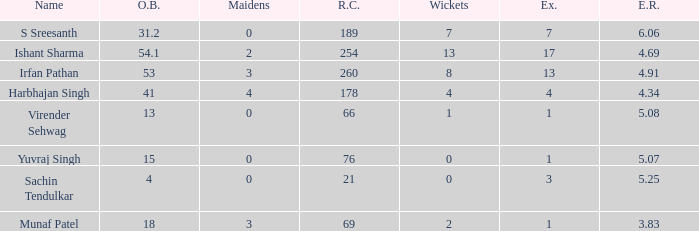Would you be able to parse every entry in this table? {'header': ['Name', 'O.B.', 'Maidens', 'R.C.', 'Wickets', 'Ex.', 'E.R.'], 'rows': [['S Sreesanth', '31.2', '0', '189', '7', '7', '6.06'], ['Ishant Sharma', '54.1', '2', '254', '13', '17', '4.69'], ['Irfan Pathan', '53', '3', '260', '8', '13', '4.91'], ['Harbhajan Singh', '41', '4', '178', '4', '4', '4.34'], ['Virender Sehwag', '13', '0', '66', '1', '1', '5.08'], ['Yuvraj Singh', '15', '0', '76', '0', '1', '5.07'], ['Sachin Tendulkar', '4', '0', '21', '0', '3', '5.25'], ['Munaf Patel', '18', '3', '69', '2', '1', '3.83']]} Name the wickets for overs bowled being 15 0.0. 